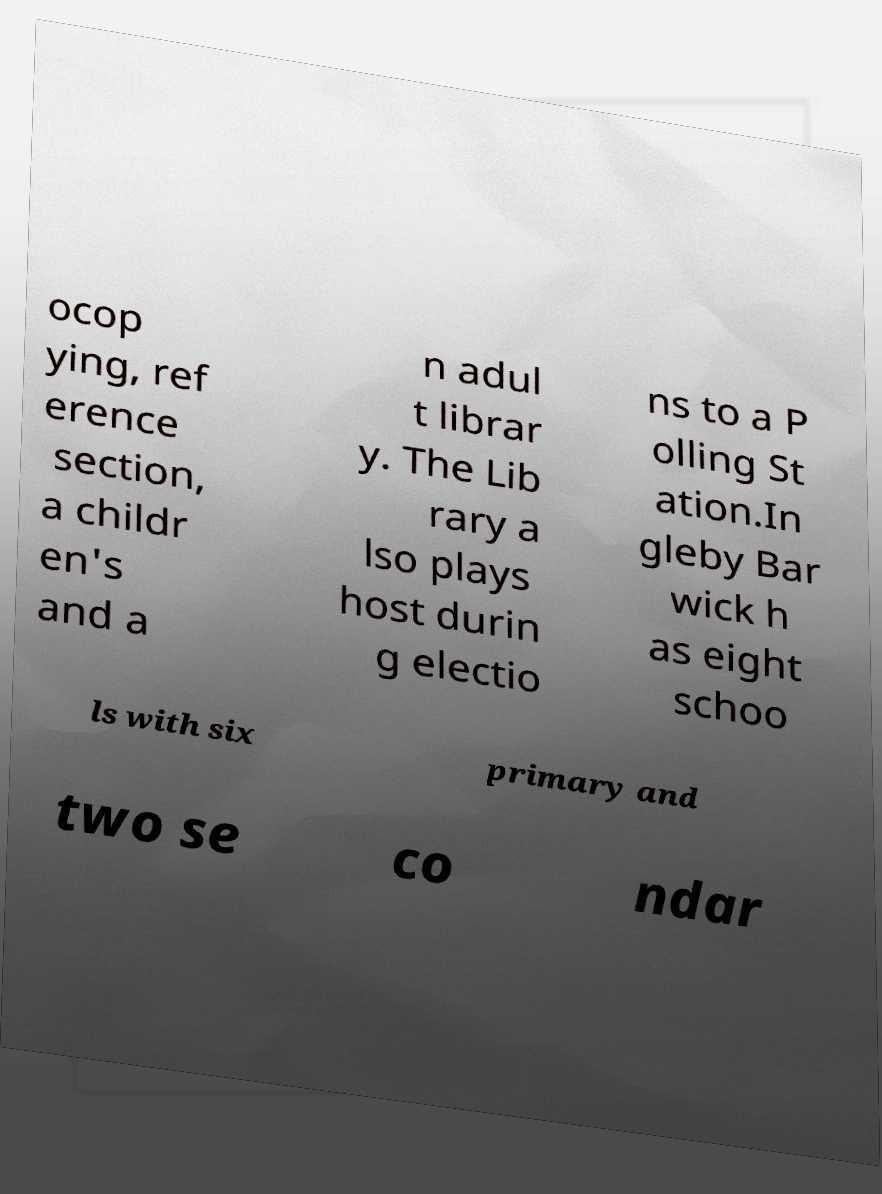I need the written content from this picture converted into text. Can you do that? ocop ying, ref erence section, a childr en's and a n adul t librar y. The Lib rary a lso plays host durin g electio ns to a P olling St ation.In gleby Bar wick h as eight schoo ls with six primary and two se co ndar 